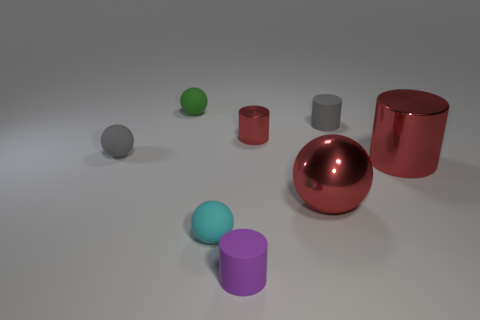Are any small cyan rubber objects visible?
Offer a very short reply. Yes. There is a rubber cylinder in front of the small ball on the left side of the green sphere; how big is it?
Give a very brief answer. Small. Is the color of the matte object left of the green ball the same as the matte cylinder that is behind the red metallic ball?
Provide a succinct answer. Yes. What color is the matte object that is behind the gray ball and on the left side of the small red shiny cylinder?
Ensure brevity in your answer.  Green. How many other things are the same shape as the cyan object?
Provide a short and direct response. 3. The other matte cylinder that is the same size as the gray cylinder is what color?
Offer a terse response. Purple. There is a sphere that is behind the small shiny cylinder; what is its color?
Provide a succinct answer. Green. Is there a small sphere that is behind the small rubber cylinder that is behind the small purple thing?
Your response must be concise. Yes. Does the green rubber object have the same shape as the big red metallic object that is to the left of the large metal cylinder?
Provide a short and direct response. Yes. How big is the cylinder that is both behind the small purple object and on the left side of the red metallic ball?
Make the answer very short. Small. 